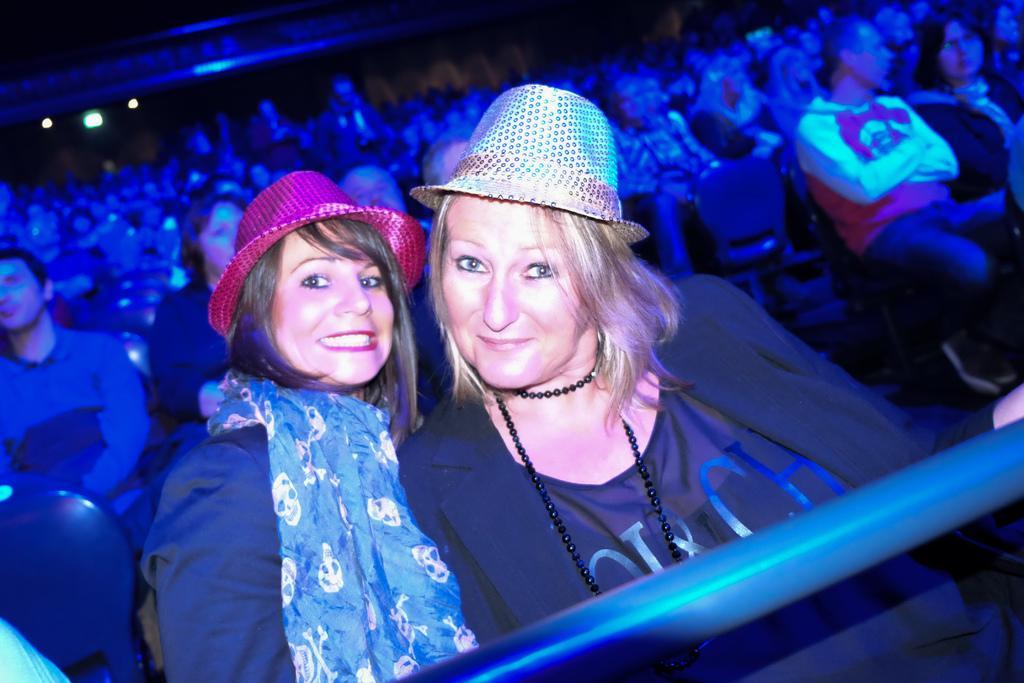Could you give a brief overview of what you see in this image? In this image we can see people are sitting on chairs. In-front of these women there is a rod. Background it is blur. These two women wore hats. Far there are lights.  